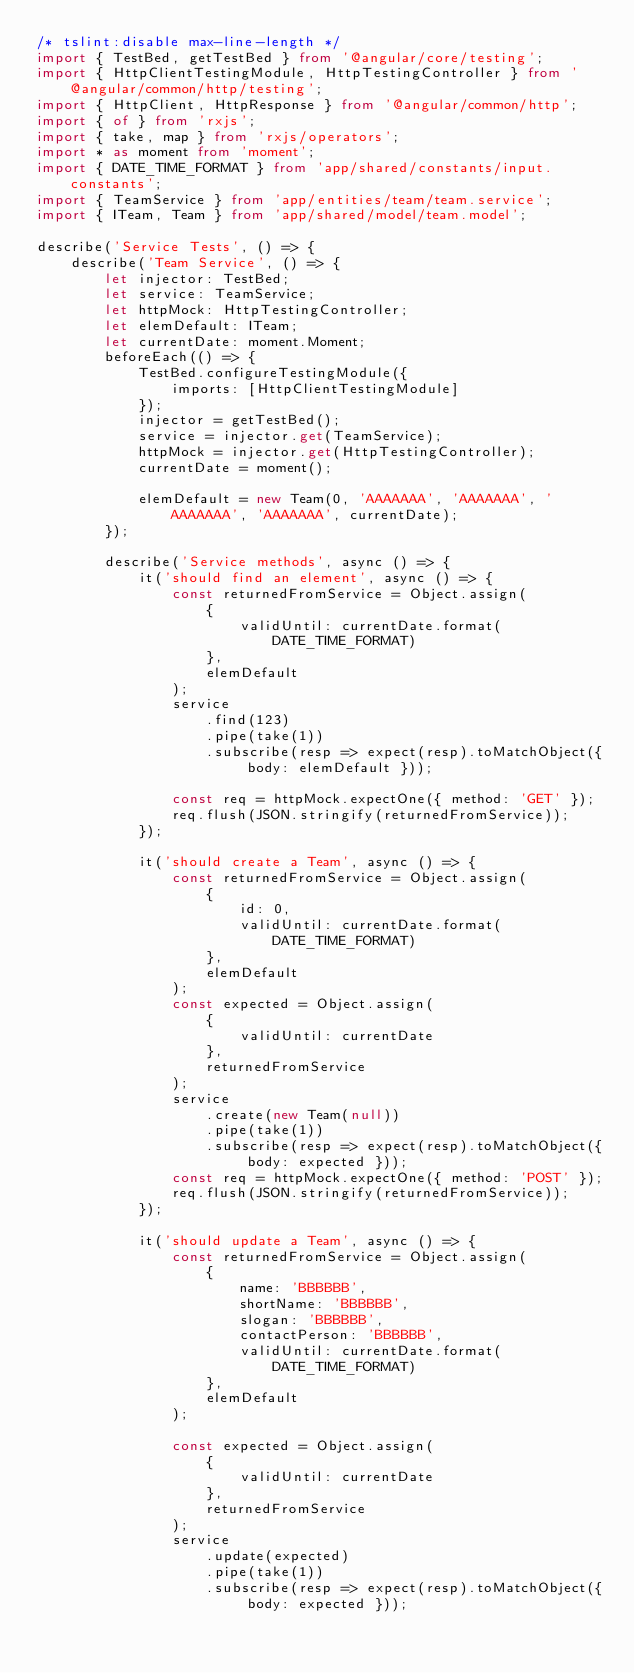<code> <loc_0><loc_0><loc_500><loc_500><_TypeScript_>/* tslint:disable max-line-length */
import { TestBed, getTestBed } from '@angular/core/testing';
import { HttpClientTestingModule, HttpTestingController } from '@angular/common/http/testing';
import { HttpClient, HttpResponse } from '@angular/common/http';
import { of } from 'rxjs';
import { take, map } from 'rxjs/operators';
import * as moment from 'moment';
import { DATE_TIME_FORMAT } from 'app/shared/constants/input.constants';
import { TeamService } from 'app/entities/team/team.service';
import { ITeam, Team } from 'app/shared/model/team.model';

describe('Service Tests', () => {
    describe('Team Service', () => {
        let injector: TestBed;
        let service: TeamService;
        let httpMock: HttpTestingController;
        let elemDefault: ITeam;
        let currentDate: moment.Moment;
        beforeEach(() => {
            TestBed.configureTestingModule({
                imports: [HttpClientTestingModule]
            });
            injector = getTestBed();
            service = injector.get(TeamService);
            httpMock = injector.get(HttpTestingController);
            currentDate = moment();

            elemDefault = new Team(0, 'AAAAAAA', 'AAAAAAA', 'AAAAAAA', 'AAAAAAA', currentDate);
        });

        describe('Service methods', async () => {
            it('should find an element', async () => {
                const returnedFromService = Object.assign(
                    {
                        validUntil: currentDate.format(DATE_TIME_FORMAT)
                    },
                    elemDefault
                );
                service
                    .find(123)
                    .pipe(take(1))
                    .subscribe(resp => expect(resp).toMatchObject({ body: elemDefault }));

                const req = httpMock.expectOne({ method: 'GET' });
                req.flush(JSON.stringify(returnedFromService));
            });

            it('should create a Team', async () => {
                const returnedFromService = Object.assign(
                    {
                        id: 0,
                        validUntil: currentDate.format(DATE_TIME_FORMAT)
                    },
                    elemDefault
                );
                const expected = Object.assign(
                    {
                        validUntil: currentDate
                    },
                    returnedFromService
                );
                service
                    .create(new Team(null))
                    .pipe(take(1))
                    .subscribe(resp => expect(resp).toMatchObject({ body: expected }));
                const req = httpMock.expectOne({ method: 'POST' });
                req.flush(JSON.stringify(returnedFromService));
            });

            it('should update a Team', async () => {
                const returnedFromService = Object.assign(
                    {
                        name: 'BBBBBB',
                        shortName: 'BBBBBB',
                        slogan: 'BBBBBB',
                        contactPerson: 'BBBBBB',
                        validUntil: currentDate.format(DATE_TIME_FORMAT)
                    },
                    elemDefault
                );

                const expected = Object.assign(
                    {
                        validUntil: currentDate
                    },
                    returnedFromService
                );
                service
                    .update(expected)
                    .pipe(take(1))
                    .subscribe(resp => expect(resp).toMatchObject({ body: expected }));</code> 